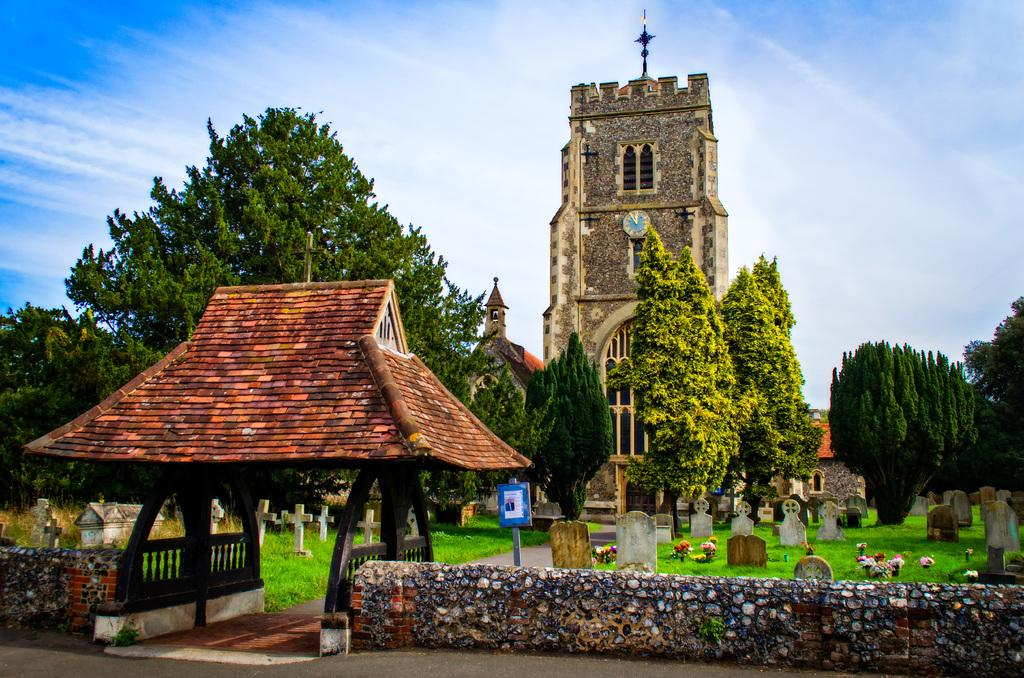What type of structures can be seen in the image? There are buildings in the image. What type of vegetation is present in the image? There are trees in the image. What type of barrier can be seen in the image? There is a wall in the image. What type of burial ground is present in the image? There are cemeteries in the image. What type of ground cover is present in the image? There is grass in the image. What type of decorative plants are present in the image? There are flowers in the image. What type of pathway is present in the image? There is a walkway at the bottom of the image. What part of the natural environment is visible in the image? The sky is visible at the top of the image. What type of country is depicted in the image? The image does not depict a country; it shows a landscape with buildings, trees, a wall, cemeteries, grass, flowers, a walkway, and sky. What type of father is present in the image? There is no father present in the image. 